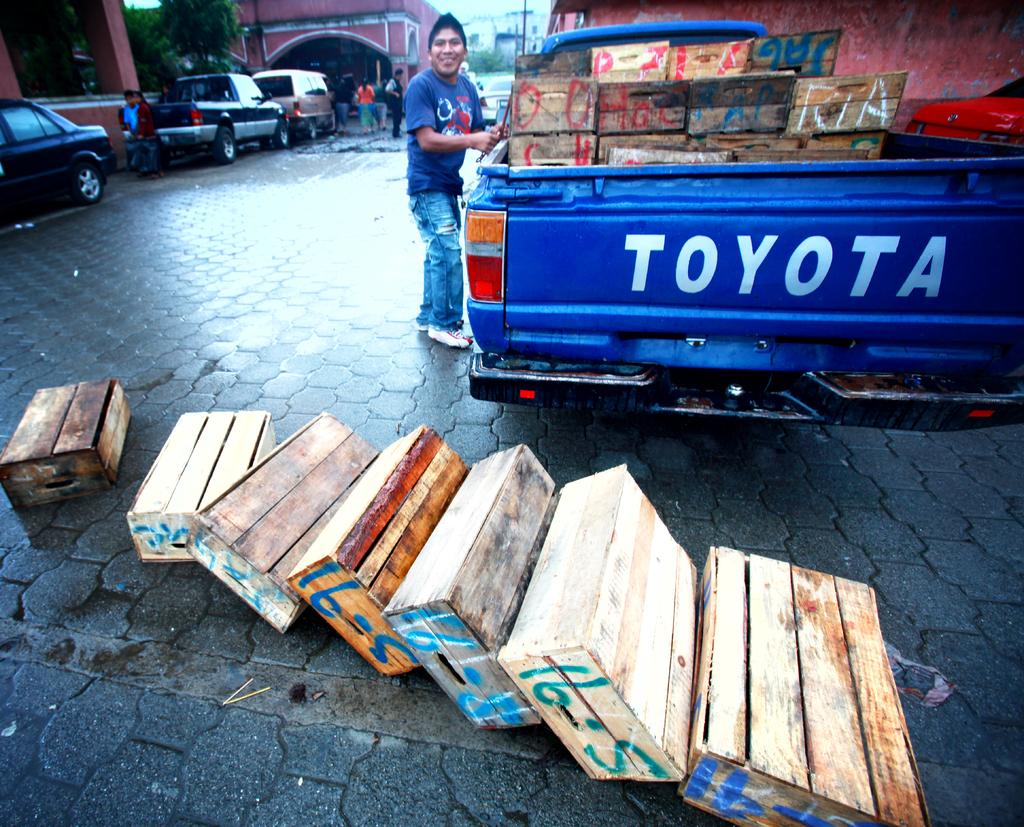What types of objects can be seen in the image? There are vehicles, wooden boxes, buildings, trees, and a pole in the image. Are there any living beings present in the image? Yes, there are people in the image. What is the setting of the image? The image features a road at the bottom, suggesting it is an outdoor scene. What can be seen in the background of the image? There are buildings and trees in the background of the image. What type of crime is being committed in the image? There is no indication of any crime being committed in the image. What color are the teeth of the person in the image? There are no teeth visible in the image, as it features vehicles, wooden boxes, buildings, trees, people, a pole, and a road. 